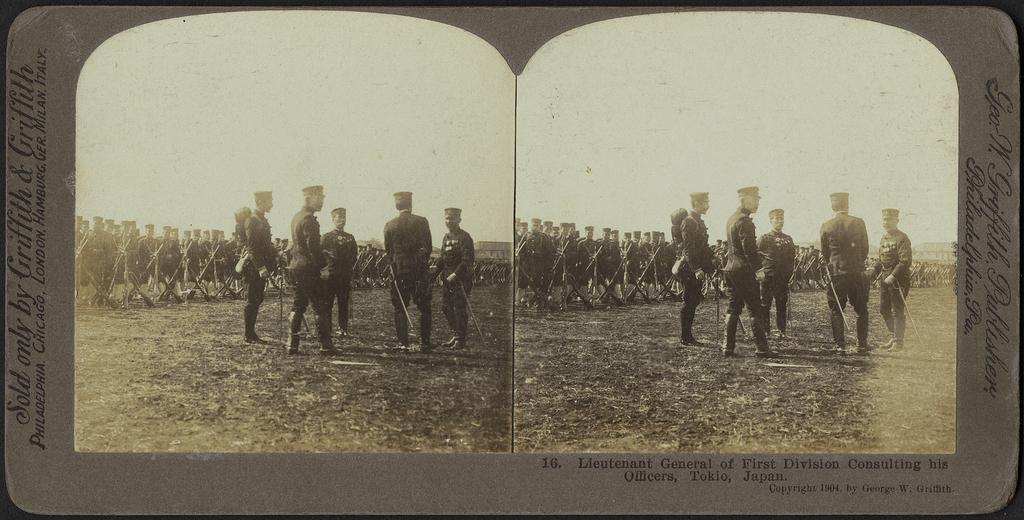What type of photograph is in the image? There is an old college photograph in the image. Who is featured in the photograph? The photograph features a military group. Where are the military group members positioned in the image? The military group is standing in the front of the image. What can be seen in the background of the image? There are many soldiers in the background of the image. What are the soldiers in the background holding? The soldiers in the background are holding guns. What type of insurance policy is being discussed by the soldiers in the image? There is no indication in the image that the soldiers are discussing insurance policies. 